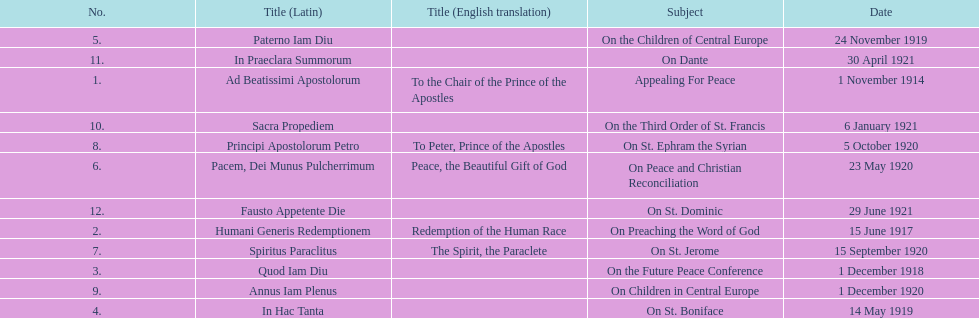What is the only subject on 23 may 1920? On Peace and Christian Reconciliation. 